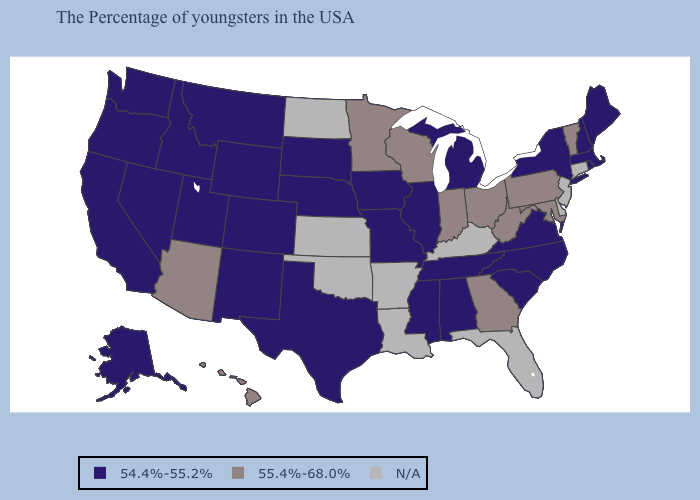What is the value of Washington?
Write a very short answer. 54.4%-55.2%. Does Maryland have the lowest value in the USA?
Write a very short answer. No. Among the states that border Maryland , which have the lowest value?
Answer briefly. Virginia. What is the lowest value in the Northeast?
Concise answer only. 54.4%-55.2%. Name the states that have a value in the range 54.4%-55.2%?
Keep it brief. Maine, Massachusetts, Rhode Island, New Hampshire, New York, Virginia, North Carolina, South Carolina, Michigan, Alabama, Tennessee, Illinois, Mississippi, Missouri, Iowa, Nebraska, Texas, South Dakota, Wyoming, Colorado, New Mexico, Utah, Montana, Idaho, Nevada, California, Washington, Oregon, Alaska. What is the lowest value in states that border Arizona?
Answer briefly. 54.4%-55.2%. Name the states that have a value in the range 54.4%-55.2%?
Give a very brief answer. Maine, Massachusetts, Rhode Island, New Hampshire, New York, Virginia, North Carolina, South Carolina, Michigan, Alabama, Tennessee, Illinois, Mississippi, Missouri, Iowa, Nebraska, Texas, South Dakota, Wyoming, Colorado, New Mexico, Utah, Montana, Idaho, Nevada, California, Washington, Oregon, Alaska. Which states have the lowest value in the USA?
Keep it brief. Maine, Massachusetts, Rhode Island, New Hampshire, New York, Virginia, North Carolina, South Carolina, Michigan, Alabama, Tennessee, Illinois, Mississippi, Missouri, Iowa, Nebraska, Texas, South Dakota, Wyoming, Colorado, New Mexico, Utah, Montana, Idaho, Nevada, California, Washington, Oregon, Alaska. What is the value of California?
Short answer required. 54.4%-55.2%. Name the states that have a value in the range 55.4%-68.0%?
Keep it brief. Vermont, Maryland, Pennsylvania, West Virginia, Ohio, Georgia, Indiana, Wisconsin, Minnesota, Arizona, Hawaii. Name the states that have a value in the range 55.4%-68.0%?
Be succinct. Vermont, Maryland, Pennsylvania, West Virginia, Ohio, Georgia, Indiana, Wisconsin, Minnesota, Arizona, Hawaii. Among the states that border Illinois , does Iowa have the lowest value?
Short answer required. Yes. Which states hav the highest value in the Northeast?
Quick response, please. Vermont, Pennsylvania. 